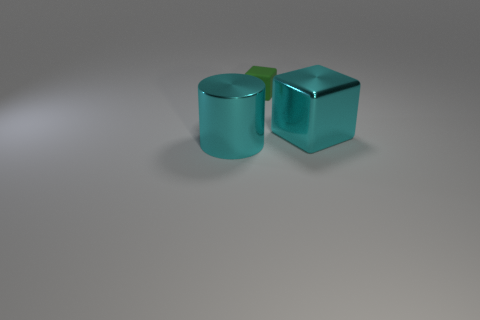Is there any indication of the size of these objects? There are no clear indicators of scale such as a reference object within the image. However, based on common object sizes, we might infer that they are similar in size to household items like mugs or small containers. 